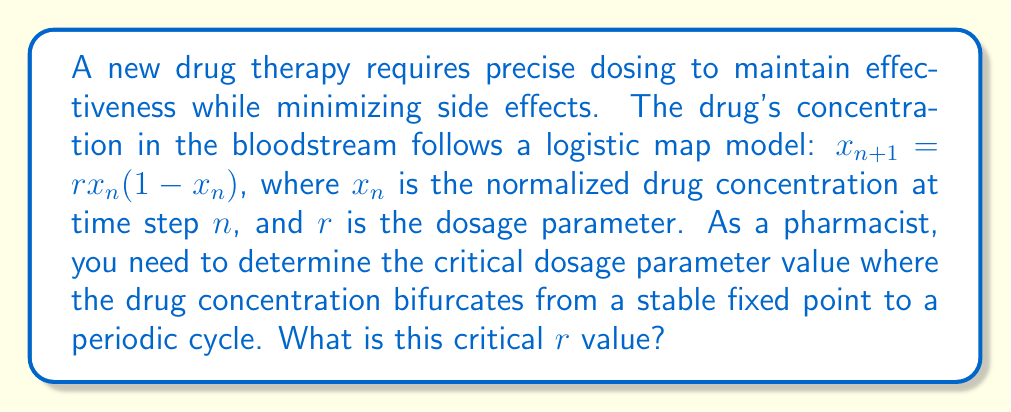Provide a solution to this math problem. To solve this problem, we need to analyze the bifurcation of the logistic map:

1. The logistic map is given by: $x_{n+1} = rx_n(1-x_n)$

2. For a fixed point $x^*$, we have: $x^* = rx^*(1-x^*)$

3. Solving this equation, we find two fixed points:
   $x^* = 0$ and $x^* = 1 - \frac{1}{r}$

4. To determine stability, we calculate the derivative of the map:
   $f'(x) = r(1-2x)$

5. At the non-zero fixed point $x^* = 1 - \frac{1}{r}$, the derivative is:
   $f'(x^*) = r(1-2(1-\frac{1}{r})) = r(1-2+\frac{2}{r}) = 2-r$

6. The fixed point loses stability when $|f'(x^*)| = 1$:
   $|2-r| = 1$

7. Solving this equation:
   $2-r = 1$ or $2-r = -1$
   $r = 1$ or $r = 3$

8. The critical value where the system transitions from a stable fixed point to a periodic cycle is $r = 3$.

This critical value represents the point where the drug concentration will begin to oscillate between two values instead of stabilizing at a single value, which is crucial for maintaining safe and effective drug levels in patients.
Answer: $r = 3$ 